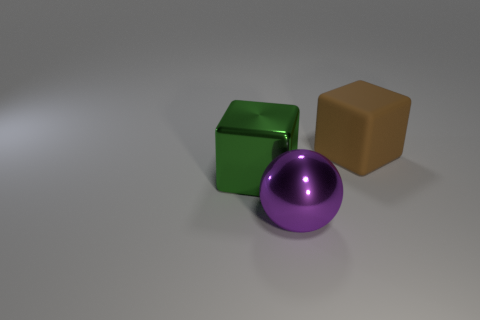Add 1 big rubber things. How many objects exist? 4 Subtract all blocks. How many objects are left? 1 Subtract 0 purple cylinders. How many objects are left? 3 Subtract all big purple metallic things. Subtract all large spheres. How many objects are left? 1 Add 3 large green cubes. How many large green cubes are left? 4 Add 1 large green blocks. How many large green blocks exist? 2 